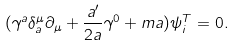Convert formula to latex. <formula><loc_0><loc_0><loc_500><loc_500>( \gamma ^ { a } \delta _ { a } ^ { \mu } \partial _ { \mu } + \frac { a ^ { \prime } } { 2 a } \gamma ^ { 0 } + m a ) \psi _ { i } ^ { T } = 0 .</formula> 